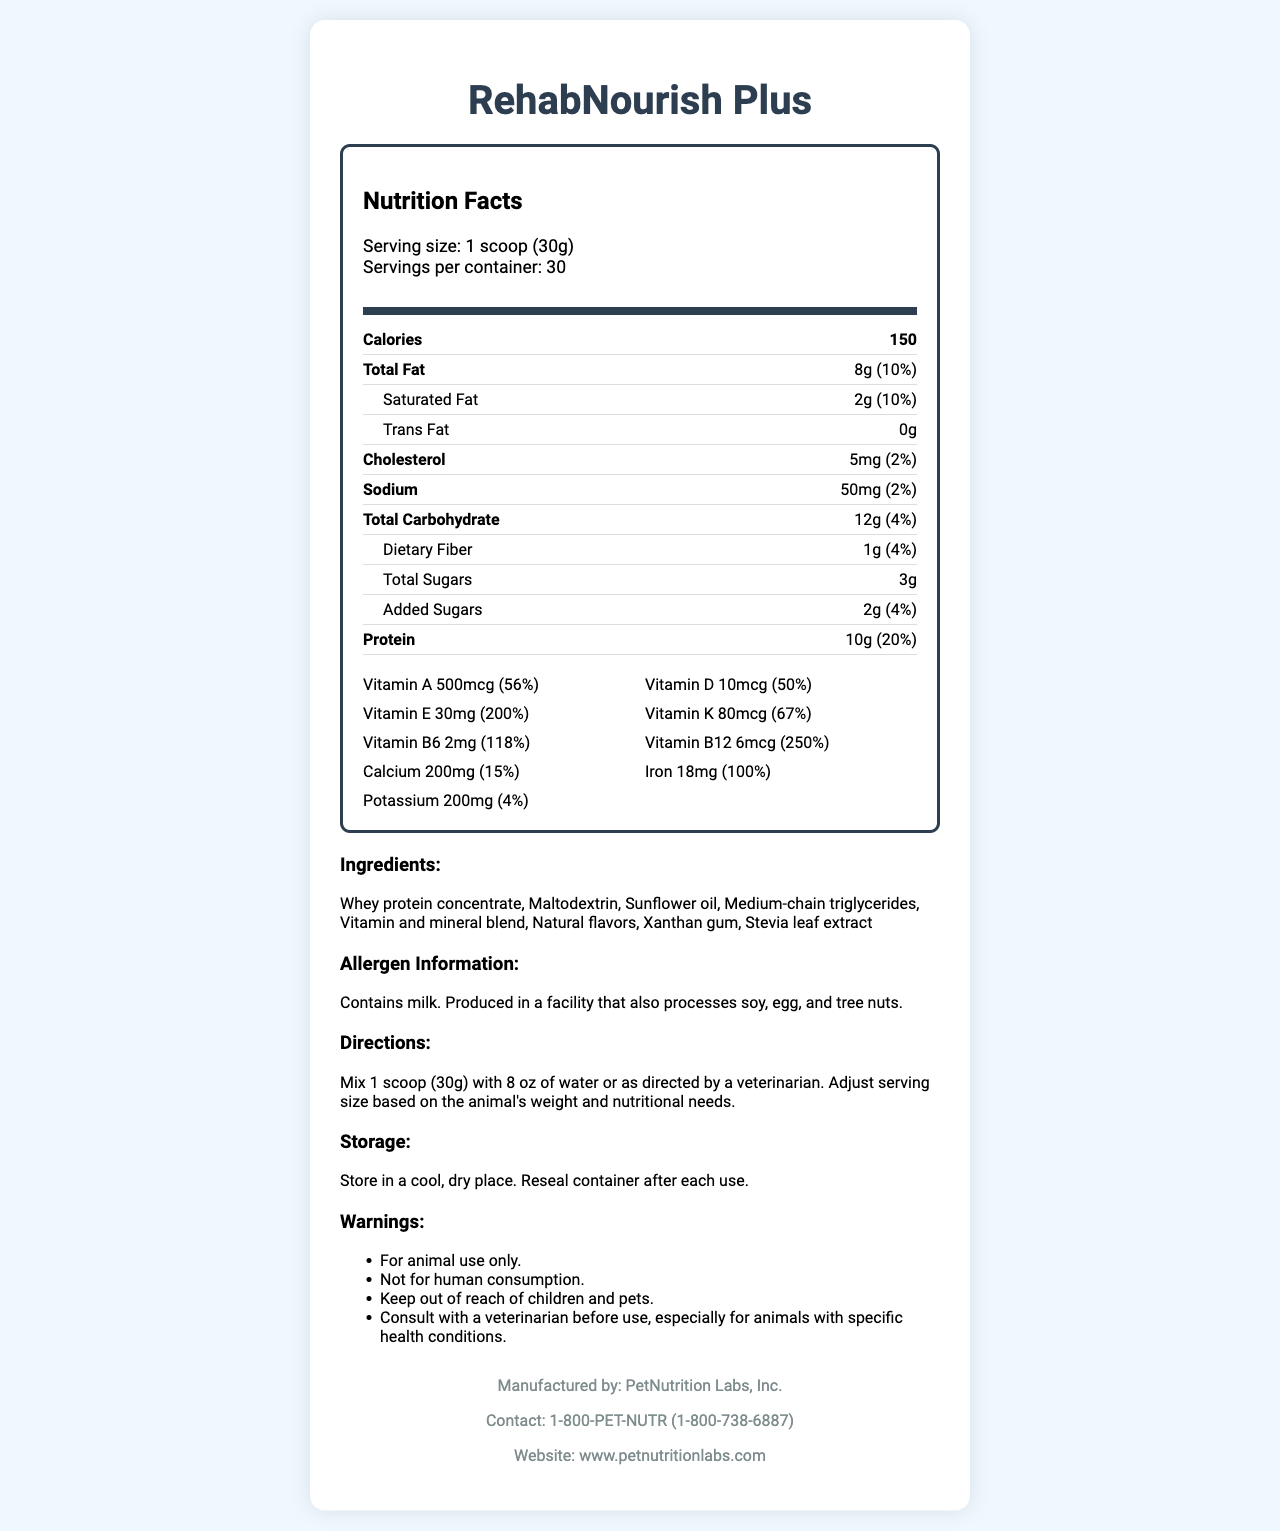what is the product name? The product name is located at the top of the document in the title and also in the main header of the Nutrition Facts section.
Answer: RehabNourish Plus what is the serving size for RehabNourish Plus? The serving size is listed just below the title in the Nutrition Facts section.
Answer: 1 scoop (30g) how many servings are there per container? The number of servings per container is given under the serving size in the Nutrition Facts section.
Answer: 30 how many calories are in each serving? The calorie count is prominently displayed in the Nutrition Facts section, in the nutrient summary.
Answer: 150 what is the total fat content per serving? Total fat per serving is clearly listed in the Nutrition Facts section under the Calories section.
Answer: 8g what is the serving direction for RehabNourish Plus? Directions for use are listed towards the end of the document in a separate "Directions" section.
Answer: Mix 1 scoop (30g) with 8 oz of water or as directed by a veterinarian. Adjust serving size based on the animal's weight and nutritional needs. does the supplement contain milk? The allergen information states that the product contains milk.
Answer: Yes who manufactures RehabNourish Plus? The manufacturer details are provided at the end of the document.
Answer: PetNutrition Labs, Inc. how much Vitamin D is in each serving? The Vitamin D content per serving is listed under the vitamins and minerals section in the Nutrition Facts.
Answer: 10mcg what is the percentage daily value of Vitamin B12 per serving? The percentage daily value for Vitamin B12 is given in the vitamins and minerals section, under Nutrition Facts.
Answer: 250% Which of the following is included in the ingredient list?
A. Maltodextrin
B. Cocoa powder
C. Rice flour The ingredient list includes Maltodextrin but not Cocoa powder or Rice flour.
Answer: A What is the daily value percentage for calcium in this supplement?
A. 10%
B. 15%
C. 20% The daily value percentage for calcium is listed as 15% in the vitamins and minerals section.
Answer: B Are there any trans fats in RehabNourish Plus? The nutrition label states that there are 0 grams of trans fat per serving.
Answer: No Does the product recommend consulting a veterinarian before use? One of the warnings mentions consulting a veterinarian before use, especially for animals with specific health conditions.
Answer: Yes can you describe the main idea of this document? The document's primary purpose is to present detailed nutritional and usage information for the supplement, aimed at ensuring proper and safe consumption by animals.
Answer: The document provides comprehensive nutrition information for a high-calorie supplement called RehabNourish Plus, designed to rehabilitate malnourished rescue animals, including details on serving size, nutritional content, ingredients, allergens, directions for use, storage information, and manufacturer details. What is the energy content in kilocalories per gram? The document lists the total calorie content per serving, but does not provide direct information on the energy content per gram.
Answer: Not enough information 